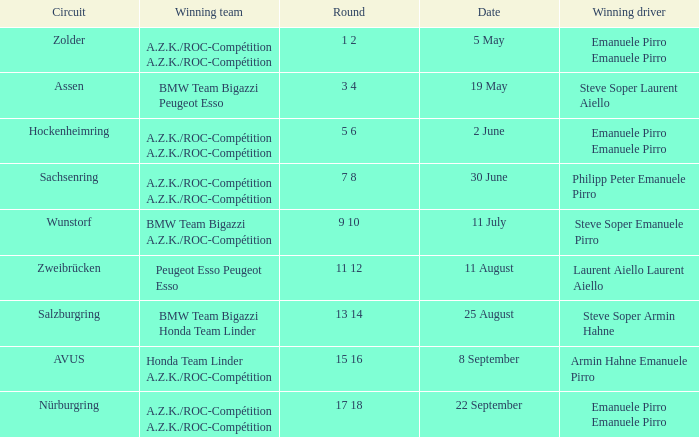What is the date of the zolder circuit, which had a.z.k./roc-compétition a.z.k./roc-compétition as the winning team? 5 May. 